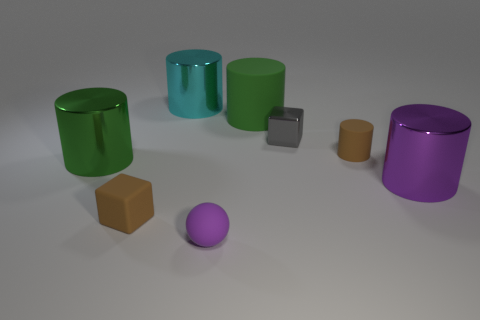Does the tiny cube that is to the left of the cyan cylinder have the same material as the brown object that is behind the big green shiny thing? Yes, the tiny grey cube to the left of the cyan cylinder appears to have a matte finish similar to the brown cube located behind the larger, glossy green cylinder. Both objects share a non-reflective surface, indicating that they may indeed have the same material with a matte texture. 